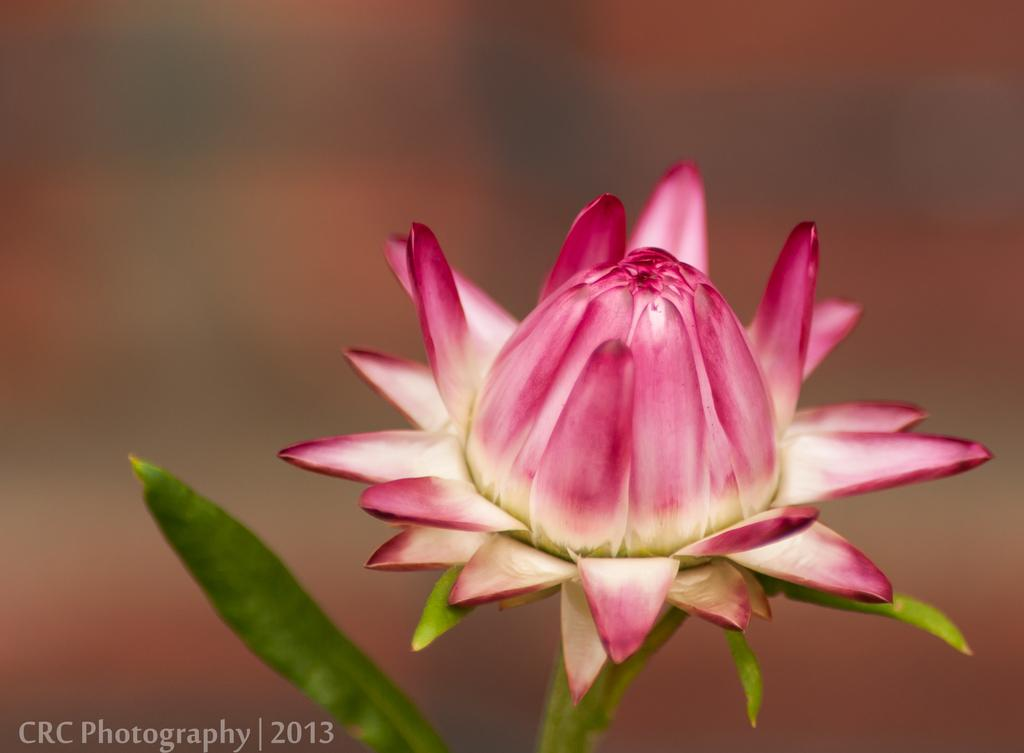What is the main subject of the image? There is a flower in the image. Can you describe the background of the image? The background of the image is blurry. Is there any text present in the image? Yes, there is some text at the left bottom of the image. How many visitors are shown in the image? There are no visitors present in the image; it features a flower and some text. What type of calendar is depicted in the image? There is no calendar present in the image. 